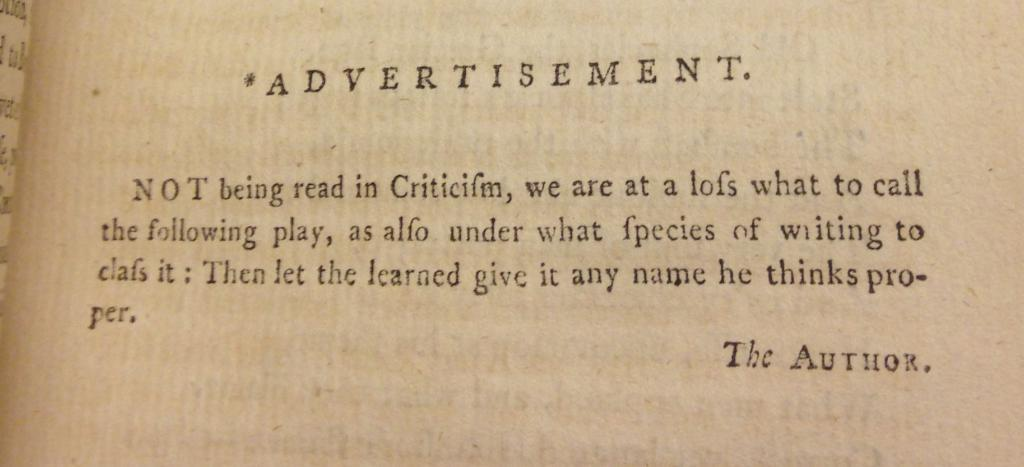<image>
Describe the image concisely. An advertisement to encourage people to see a new play. 